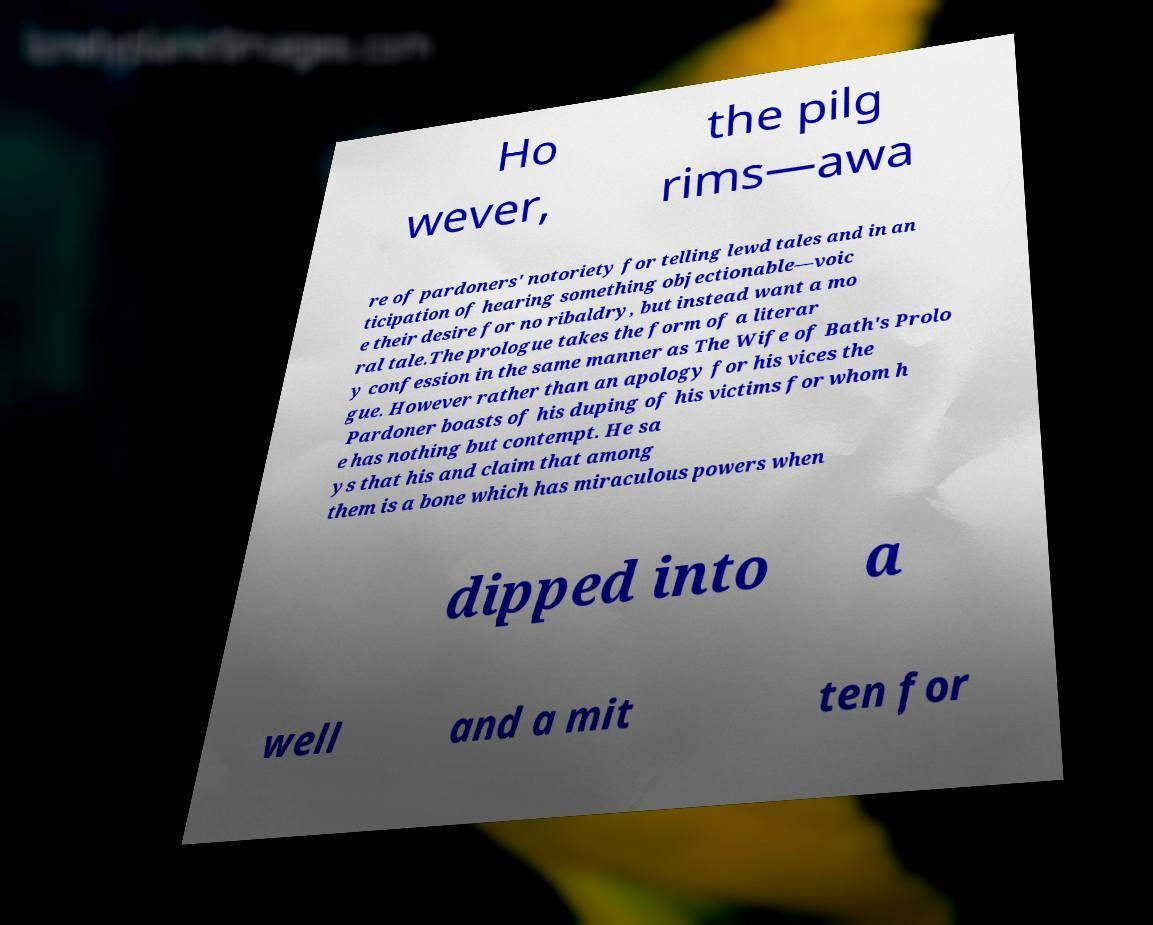Could you extract and type out the text from this image? Ho wever, the pilg rims—awa re of pardoners' notoriety for telling lewd tales and in an ticipation of hearing something objectionable—voic e their desire for no ribaldry, but instead want a mo ral tale.The prologue takes the form of a literar y confession in the same manner as The Wife of Bath's Prolo gue. However rather than an apology for his vices the Pardoner boasts of his duping of his victims for whom h e has nothing but contempt. He sa ys that his and claim that among them is a bone which has miraculous powers when dipped into a well and a mit ten for 